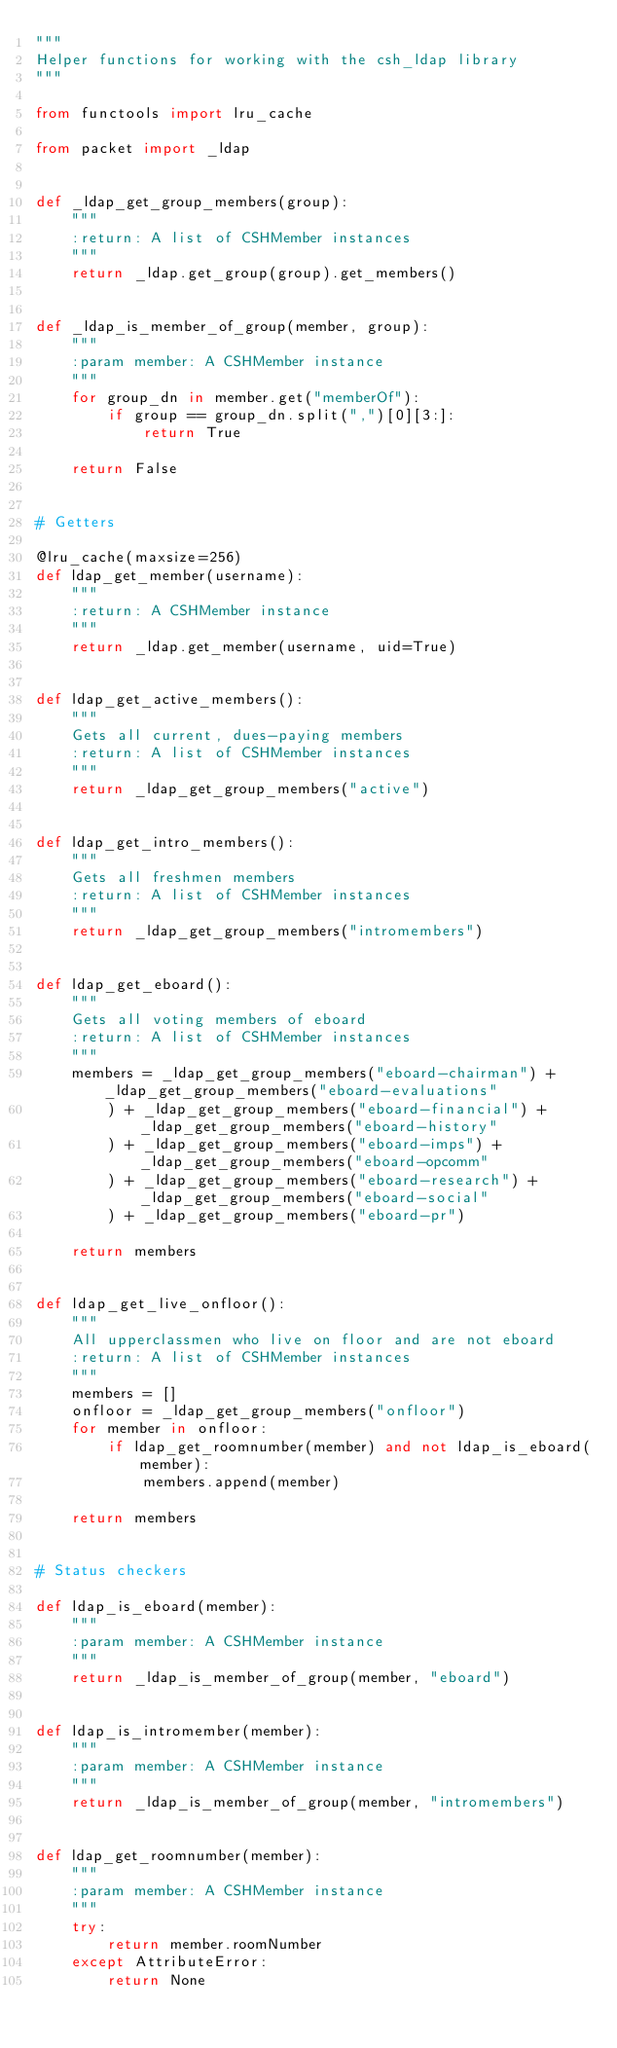<code> <loc_0><loc_0><loc_500><loc_500><_Python_>"""
Helper functions for working with the csh_ldap library
"""

from functools import lru_cache

from packet import _ldap


def _ldap_get_group_members(group):
    """
    :return: A list of CSHMember instances
    """
    return _ldap.get_group(group).get_members()


def _ldap_is_member_of_group(member, group):
    """
    :param member: A CSHMember instance
    """
    for group_dn in member.get("memberOf"):
        if group == group_dn.split(",")[0][3:]:
            return True

    return False


# Getters

@lru_cache(maxsize=256)
def ldap_get_member(username):
    """
    :return: A CSHMember instance
    """
    return _ldap.get_member(username, uid=True)


def ldap_get_active_members():
    """
    Gets all current, dues-paying members
    :return: A list of CSHMember instances
    """
    return _ldap_get_group_members("active")


def ldap_get_intro_members():
    """
    Gets all freshmen members
    :return: A list of CSHMember instances
    """
    return _ldap_get_group_members("intromembers")


def ldap_get_eboard():
    """
    Gets all voting members of eboard
    :return: A list of CSHMember instances
    """
    members = _ldap_get_group_members("eboard-chairman") + _ldap_get_group_members("eboard-evaluations"
        ) + _ldap_get_group_members("eboard-financial") + _ldap_get_group_members("eboard-history"
        ) + _ldap_get_group_members("eboard-imps") + _ldap_get_group_members("eboard-opcomm"
        ) + _ldap_get_group_members("eboard-research") + _ldap_get_group_members("eboard-social"
        ) + _ldap_get_group_members("eboard-pr")

    return members


def ldap_get_live_onfloor():
    """
    All upperclassmen who live on floor and are not eboard
    :return: A list of CSHMember instances
    """
    members = []
    onfloor = _ldap_get_group_members("onfloor")
    for member in onfloor:
        if ldap_get_roomnumber(member) and not ldap_is_eboard(member):
            members.append(member)

    return members


# Status checkers

def ldap_is_eboard(member):
    """
    :param member: A CSHMember instance
    """
    return _ldap_is_member_of_group(member, "eboard")


def ldap_is_intromember(member):
    """
    :param member: A CSHMember instance
    """
    return _ldap_is_member_of_group(member, "intromembers")


def ldap_get_roomnumber(member):
    """
    :param member: A CSHMember instance
    """
    try:
        return member.roomNumber
    except AttributeError:
        return None
</code> 